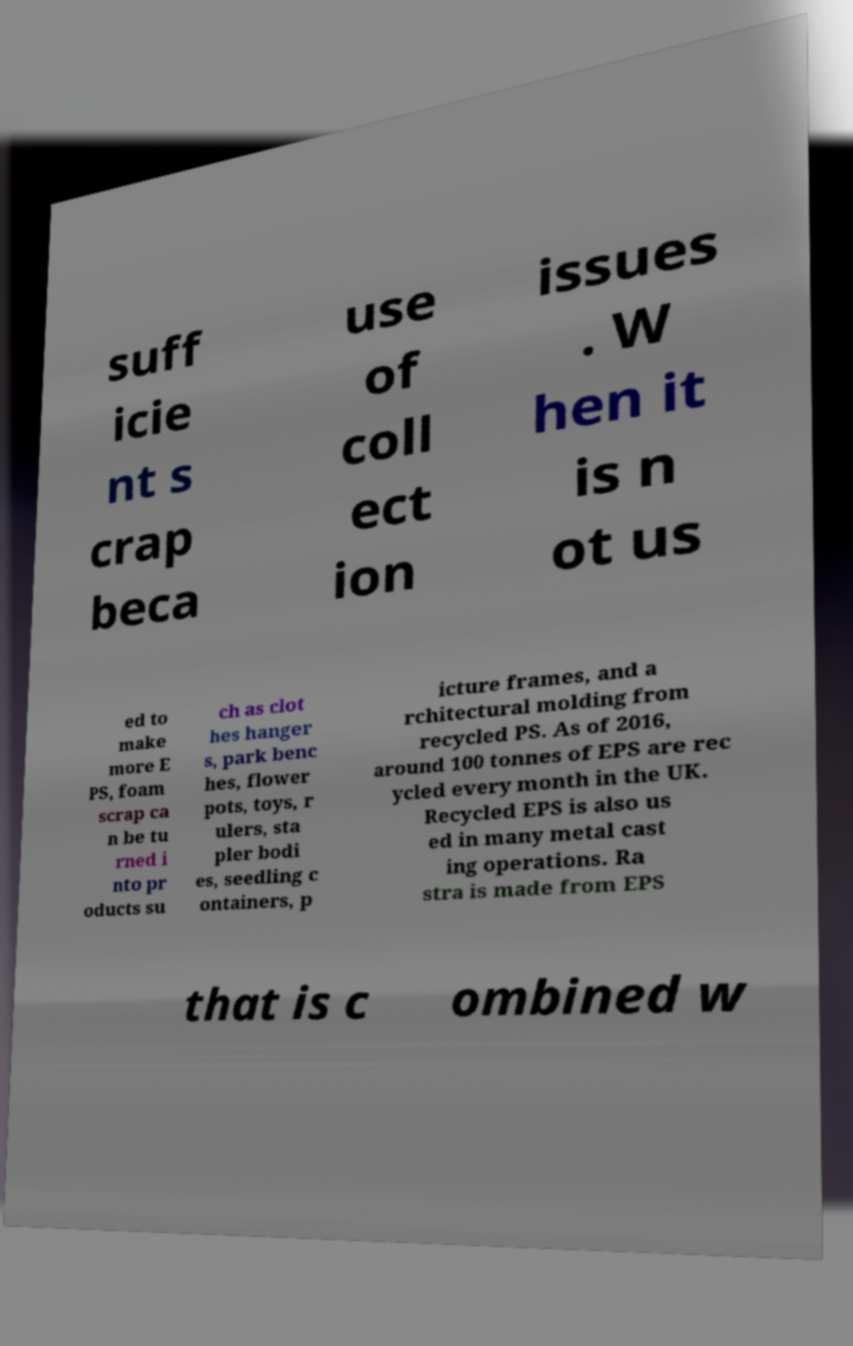Please identify and transcribe the text found in this image. suff icie nt s crap beca use of coll ect ion issues . W hen it is n ot us ed to make more E PS, foam scrap ca n be tu rned i nto pr oducts su ch as clot hes hanger s, park benc hes, flower pots, toys, r ulers, sta pler bodi es, seedling c ontainers, p icture frames, and a rchitectural molding from recycled PS. As of 2016, around 100 tonnes of EPS are rec ycled every month in the UK. Recycled EPS is also us ed in many metal cast ing operations. Ra stra is made from EPS that is c ombined w 